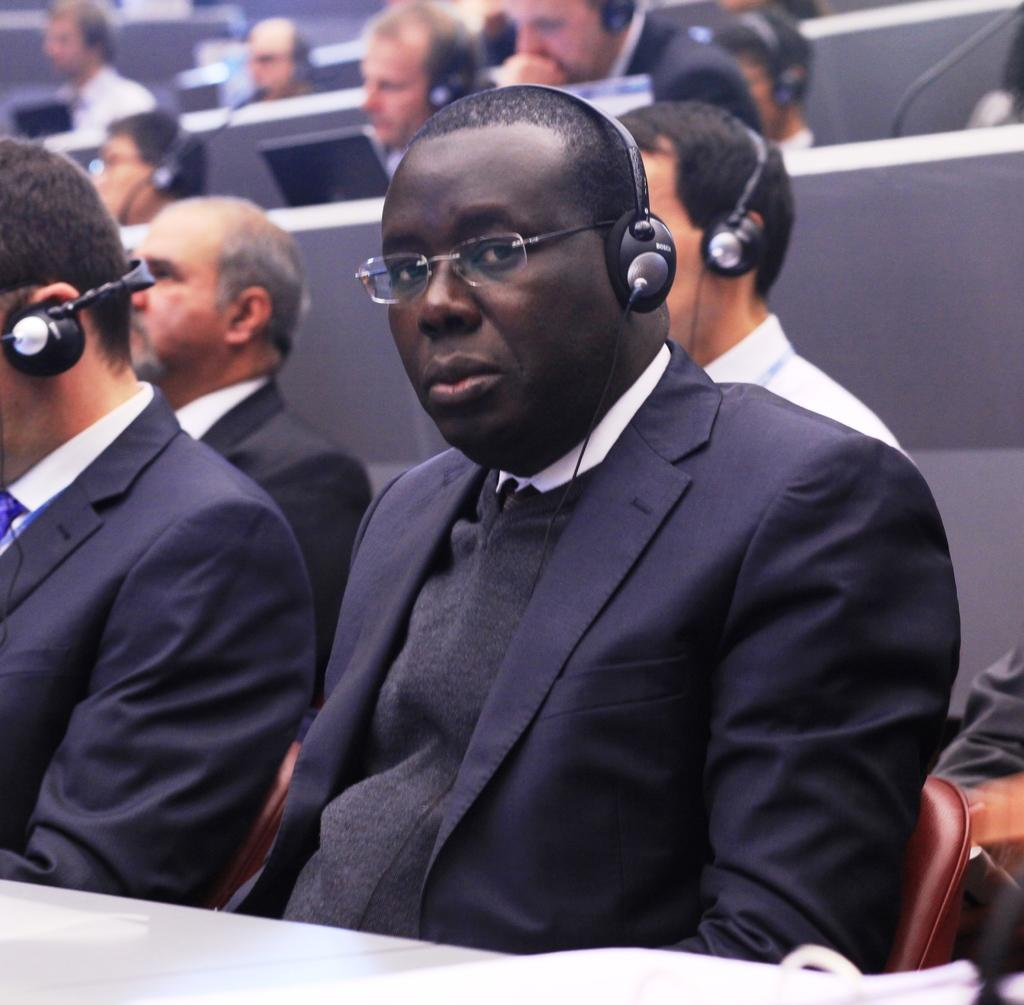What are the people in the image doing? The people in the image are sitting. What can be seen on the people's heads in the image? The people are wearing headsets. What objects are in front of the people in the image? There are tables in front of the people. What type of church can be seen in the image? There is no church present in the image. What property is being discussed by the people in the image? The image does not show any discussion or mention of property. 